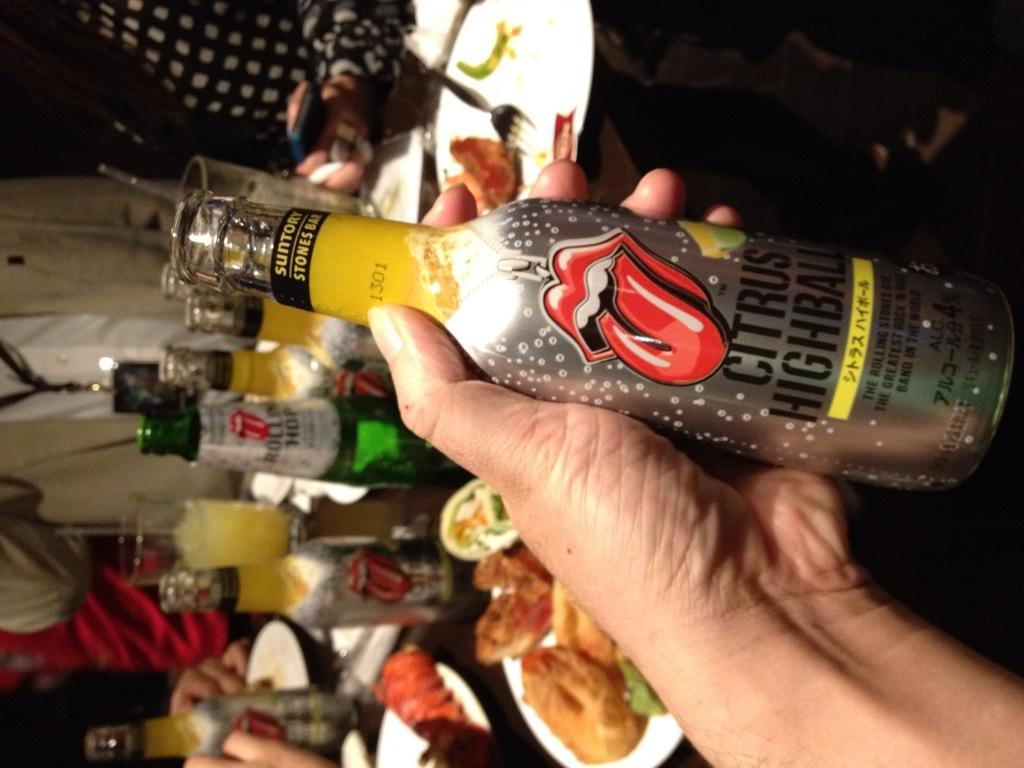What is the person in the image holding? The person is holding a bottle in the image. What can be read on the label of the bottle? The bottle is labeled 'CITRUS'. What other objects can be seen on the table in the background? There are other bottles on a table in the background. What utensil is visible in the background? There is a fork visible in the background. What achievement is the person holding the bottle celebrating in the image? There is no indication in the image of any achievement being celebrated, as the focus is on the person holding the bottle labeled 'CITRUS'. 